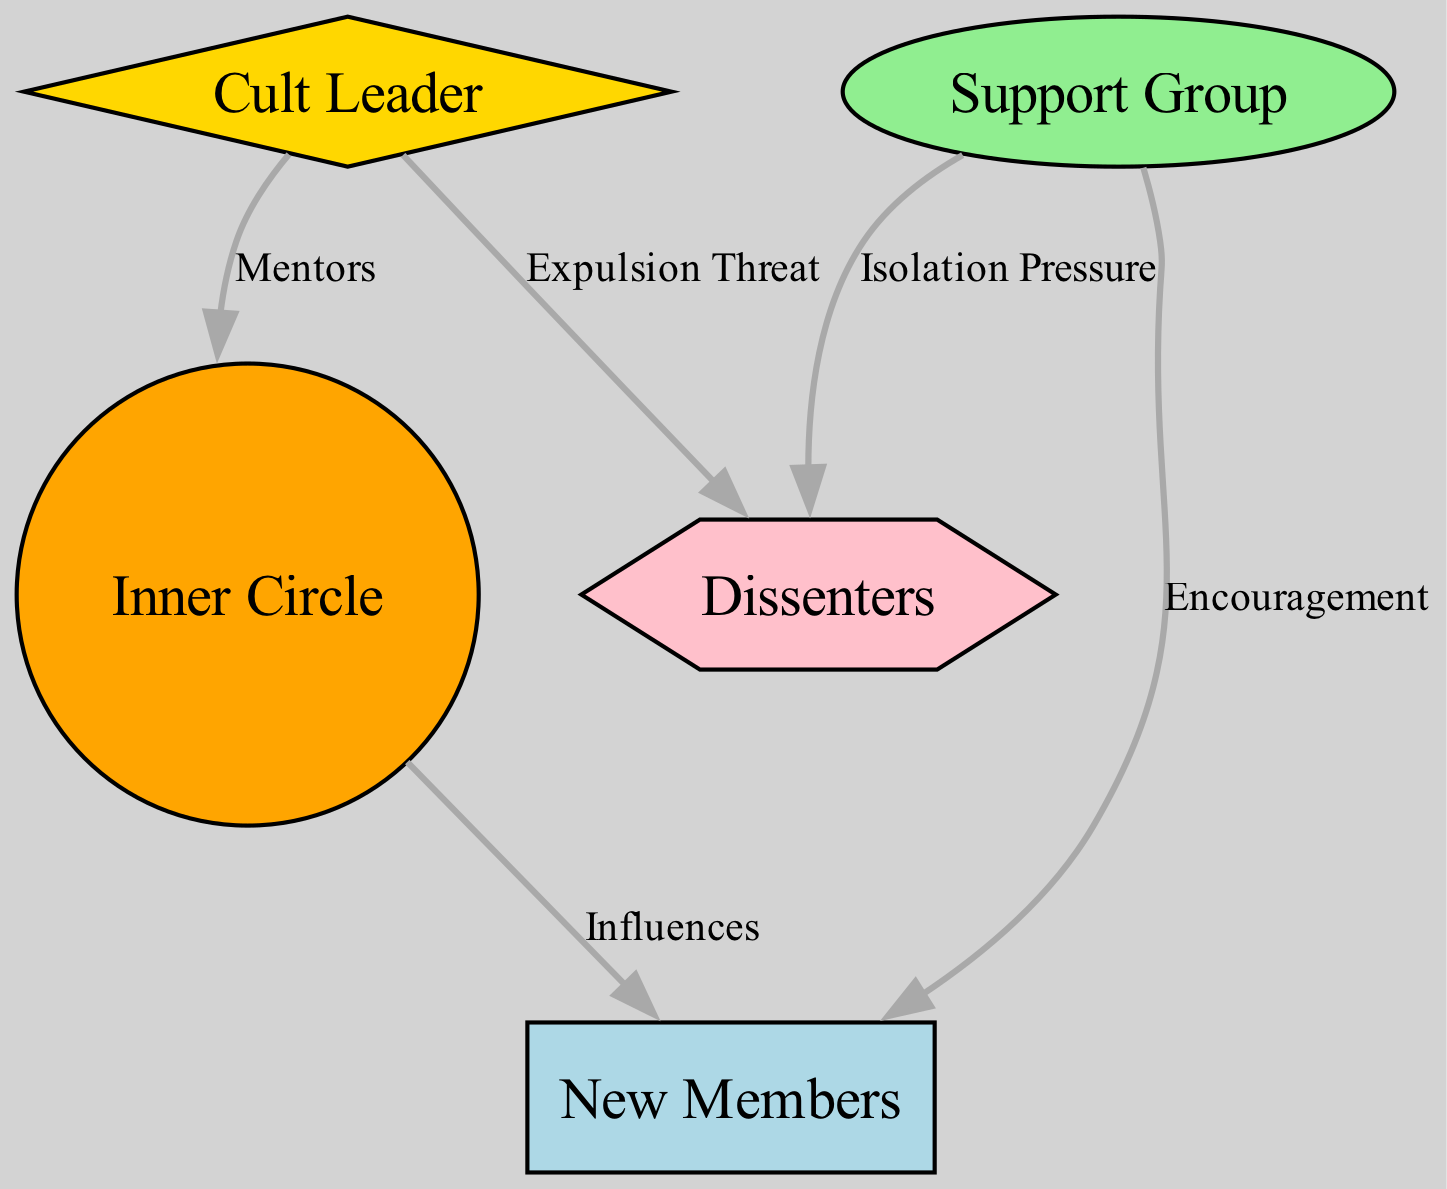What is the role of the Cult Leader in the network? The Cult Leader is depicted as the central figure who mentors the Inner Circle, indicating a leadership role that influences others.
Answer: Influences How many nodes are present in this diagram? There are five distinct nodes representing different roles or groups within the cult.
Answer: 5 What relationship exists between the Inner Circle and New Members? The diagram indicates an "Influences" relationship from Inner Circle to New Members, suggesting a guiding or persuasive dynamic.
Answer: Influences Which subgroup provides emotional support to New Members? The Support Group is identified in the diagram as the subgroup that offers encouragement to New Members, thereby helping them acclimate.
Answer: Support Group What threat is posed to Dissenters by the Cult Leader? The Cult Leader threatens expulsion to Dissenters, indicating a potential removal from the group if they oppose.
Answer: Expulsion Threat What kind of pressure does the Support Group exert on Dissenters? The Support Group applies "Isolation Pressure" to Dissenters, suggesting a form of social exclusion for those who question the group.
Answer: Isolation Pressure Which node has the shape of a diamond? In the diagram, the Cult Leader is represented as a diamond-shaped node, signifying their prominent role within the network's hierarchy.
Answer: Cult Leader How many edges connect the Cult Leader to other nodes? The Cult Leader is connected by a total of three edges to other nodes, indicating multiple relationships within the network.
Answer: 3 What does the shape of the New Members node indicate about their role? The rectangle shape of the New Members node suggests a foundational or entry-level position in the cult's hierarchy.
Answer: Rectangle Which node is threatened with expulsion? Dissenters are the members who are threatened with expulsion by the Cult Leader, indicating their position as opposed to group norms.
Answer: Dissenters 